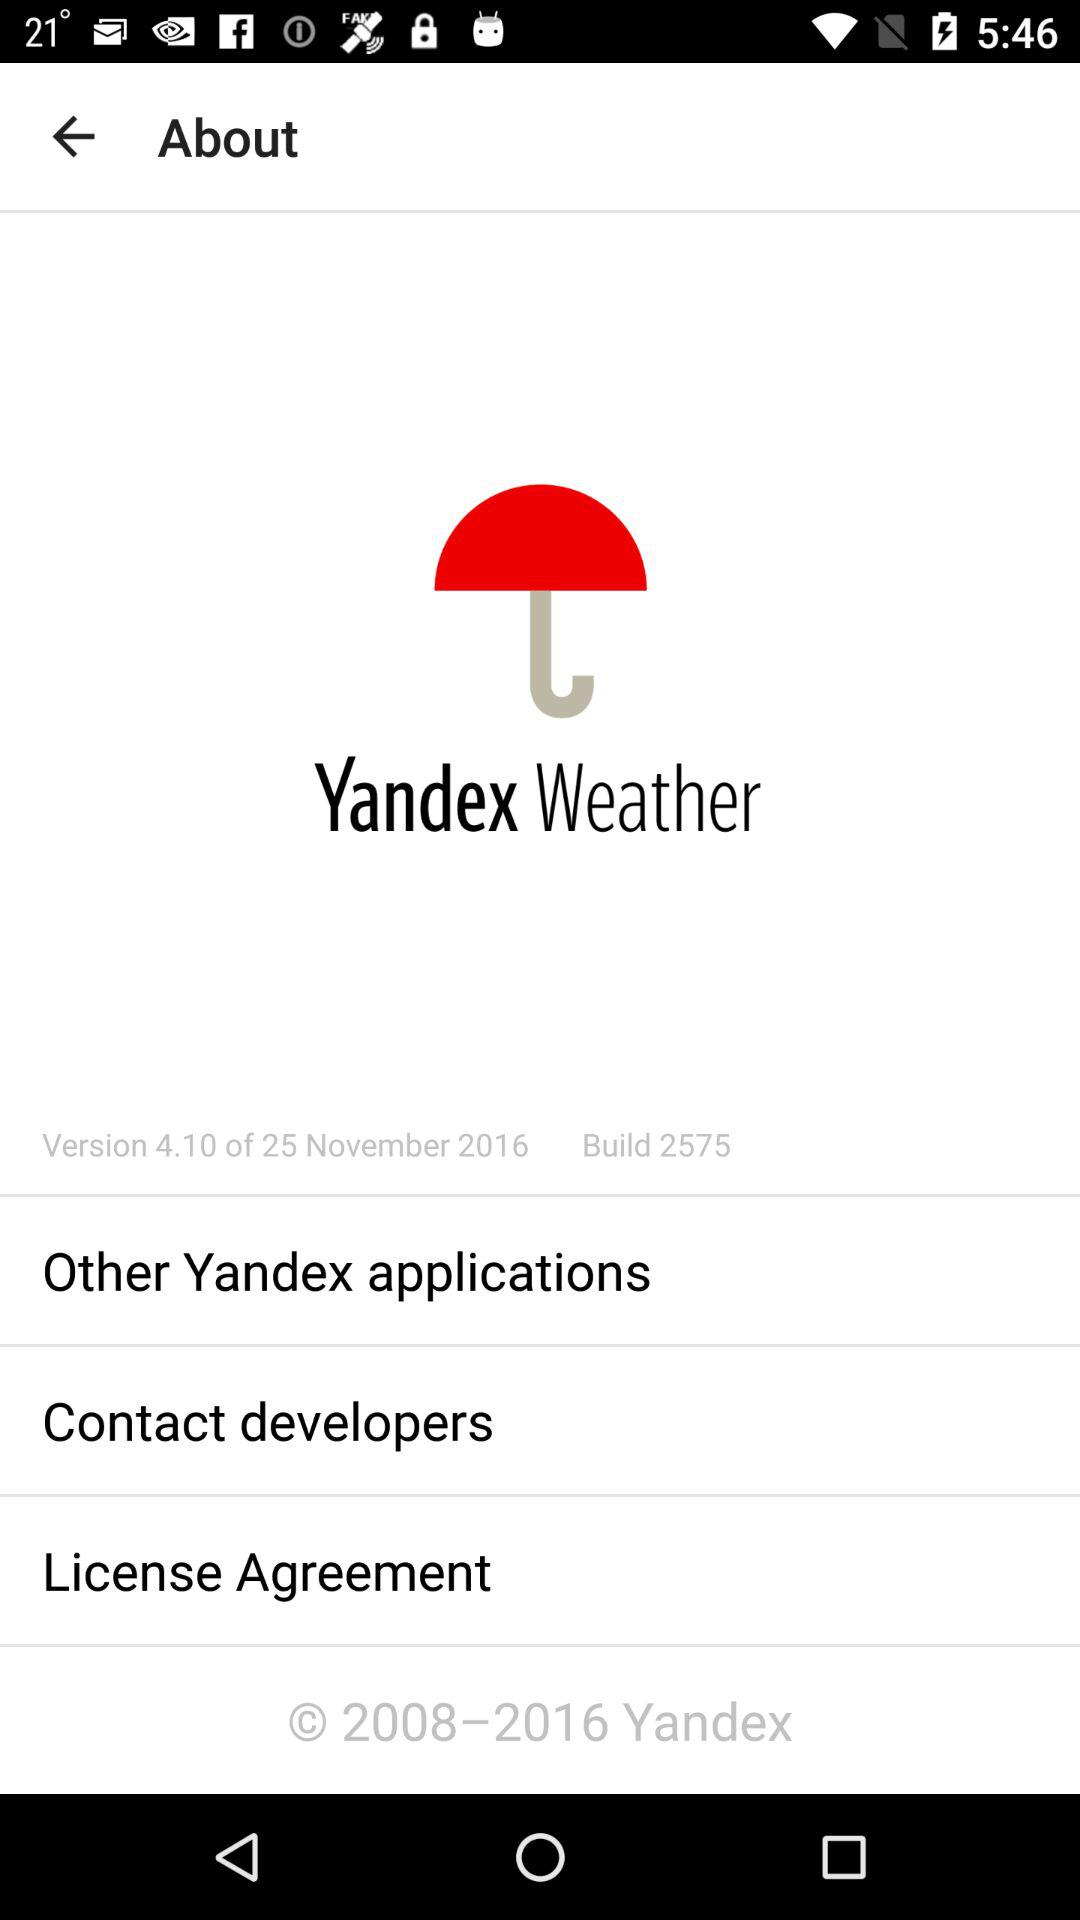What is the application name? The application name is "Yandex Weather". 